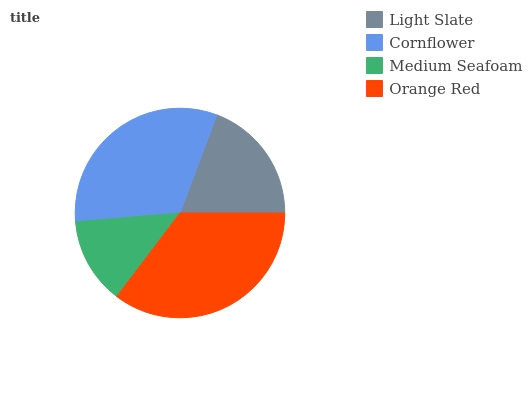Is Medium Seafoam the minimum?
Answer yes or no. Yes. Is Orange Red the maximum?
Answer yes or no. Yes. Is Cornflower the minimum?
Answer yes or no. No. Is Cornflower the maximum?
Answer yes or no. No. Is Cornflower greater than Light Slate?
Answer yes or no. Yes. Is Light Slate less than Cornflower?
Answer yes or no. Yes. Is Light Slate greater than Cornflower?
Answer yes or no. No. Is Cornflower less than Light Slate?
Answer yes or no. No. Is Cornflower the high median?
Answer yes or no. Yes. Is Light Slate the low median?
Answer yes or no. Yes. Is Orange Red the high median?
Answer yes or no. No. Is Medium Seafoam the low median?
Answer yes or no. No. 